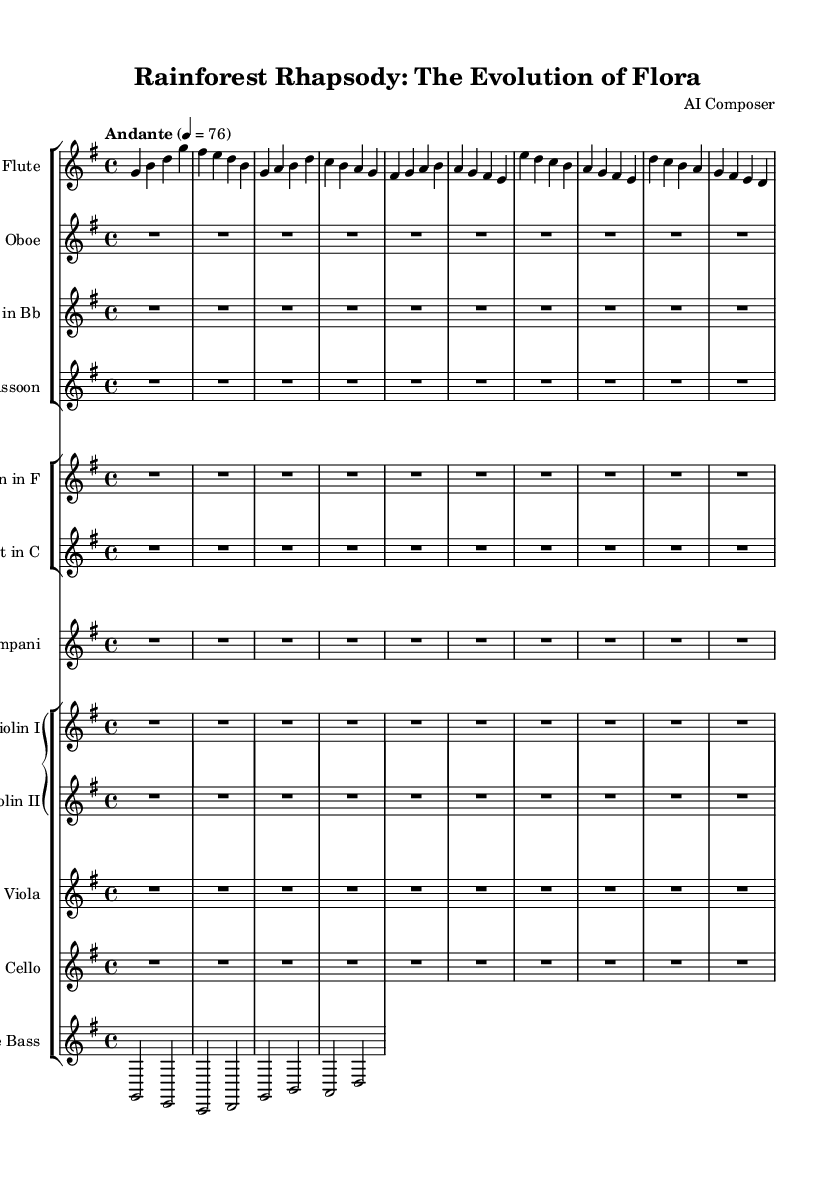What is the key signature of this music? The key signature is G major, which has one sharp (F#). This is indicated at the beginning of the staff.
Answer: G major What is the time signature of this music? The time signature is 4/4, which shows there are four beats per measure, indicated at the beginning of the score.
Answer: 4/4 What is the tempo marking of this music? The tempo marking is "Andante," indicating a moderate pace. This is specified above the first measure in the score.
Answer: Andante How many different instrument families are represented in this orchestral suite? The orchestral suite includes four families: woodwinds, brass, percussion, and strings. This can be inferred from the grouping of the instruments in the score.
Answer: Four Which instruments are in the woodwind family of this suite? The woodwind instruments listed are Flute, Oboe, Clarinet in Bb, and Bassoon, identifiable under the first staff group.
Answer: Flute, Oboe, Clarinet in Bb, Bassoon What is the first note played by the Flute? The first note played by the Flute is G, which is indicated in the first measure of the Flute staff.
Answer: G How many measures are presented for the woodwind instruments in this piece? The woodwind instruments have one measure of music presented before rest for ten beats, indicated by the 'R1*10' notation in the respective staves.
Answer: One 